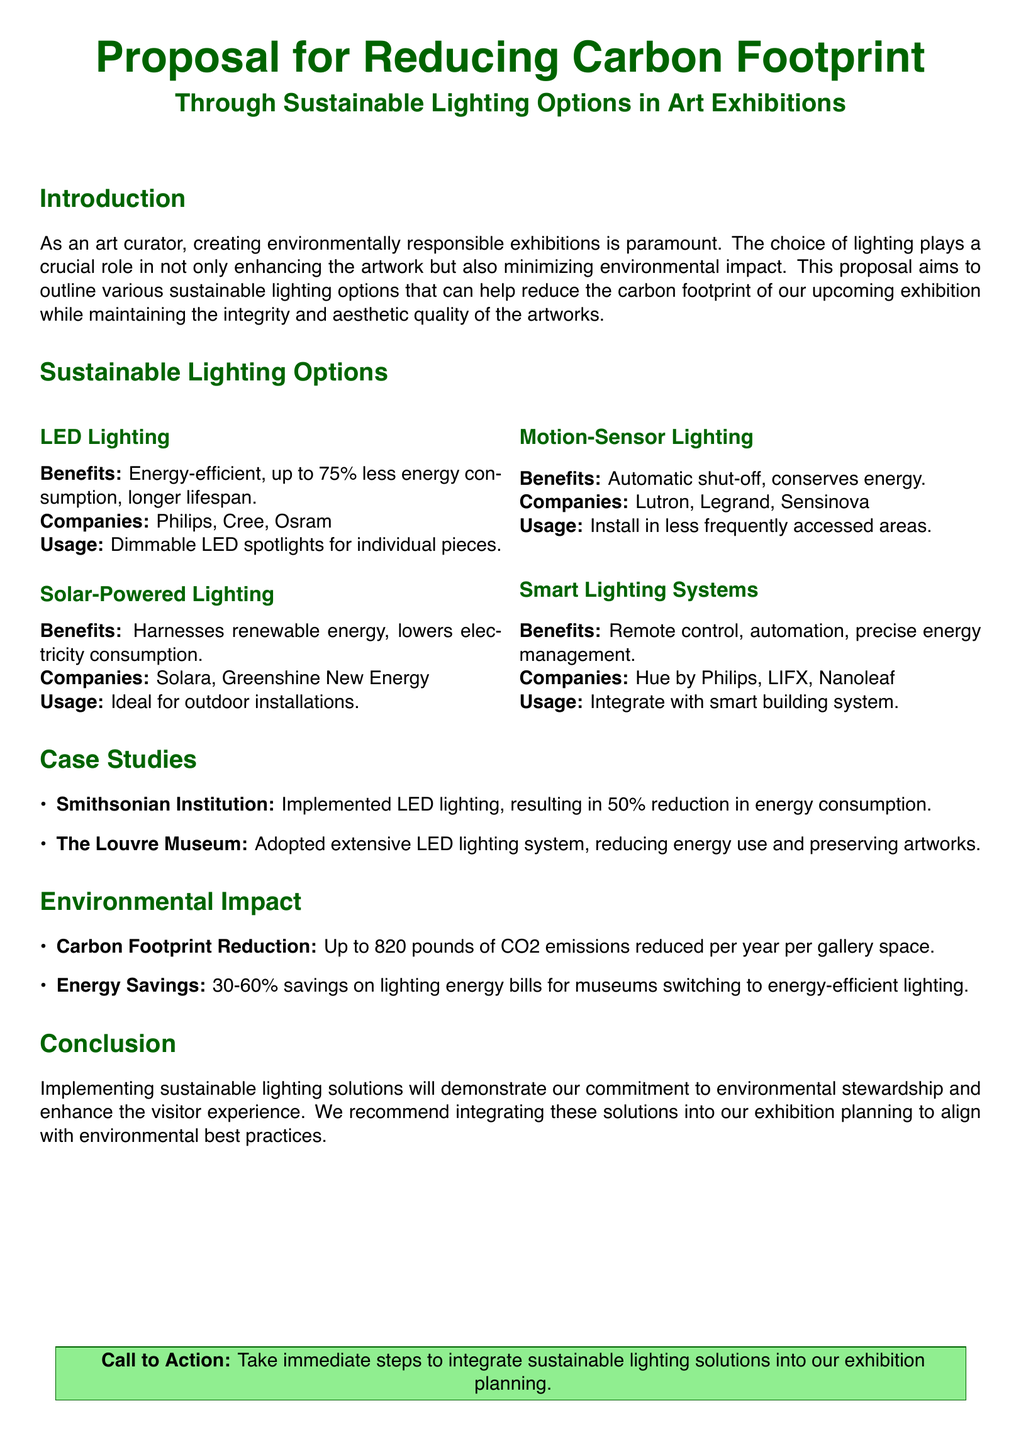What is the main goal of this proposal? The main goal of the proposal is to outline various sustainable lighting options that can help reduce the carbon footprint of the exhibition while maintaining the integrity and aesthetic quality of the artworks.
Answer: Reduce carbon footprint Which lighting option uses renewable energy? Solar-powered lighting is specified as harnessing renewable energy while lowering electricity consumption.
Answer: Solar-powered lighting What percentage of energy consumption can LED lighting reduce? The document states that LED lighting can reduce energy consumption by up to 75%.
Answer: 75% Which company is mentioned for smart lighting systems? The proposal lists Hue by Philips as a company providing smart lighting solutions.
Answer: Hue by Philips What case study mentions a 50% reduction in energy consumption? The Smithsonian Institution is noted for implementing LED lighting, resulting in a 50% reduction in energy consumption.
Answer: Smithsonian Institution How many pounds of CO2 emissions can be reduced per year per gallery space? The document indicates that up to 820 pounds of CO2 emissions can be reduced per year per gallery space.
Answer: 820 pounds What is the recommended immediate action from this proposal? The call to action at the end of the proposal is to take immediate steps to integrate sustainable lighting solutions into exhibition planning.
Answer: Integrate sustainable lighting solutions What type of lighting is ideal for outdoor installations according to the proposal? The proposal specifies that solar-powered lighting is ideal for outdoor installations.
Answer: Solar-powered lighting Which museums are mentioned as case studies in the document? Two museums are mentioned: the Smithsonian Institution and The Louvre Museum.
Answer: Smithsonian Institution, The Louvre Museum 